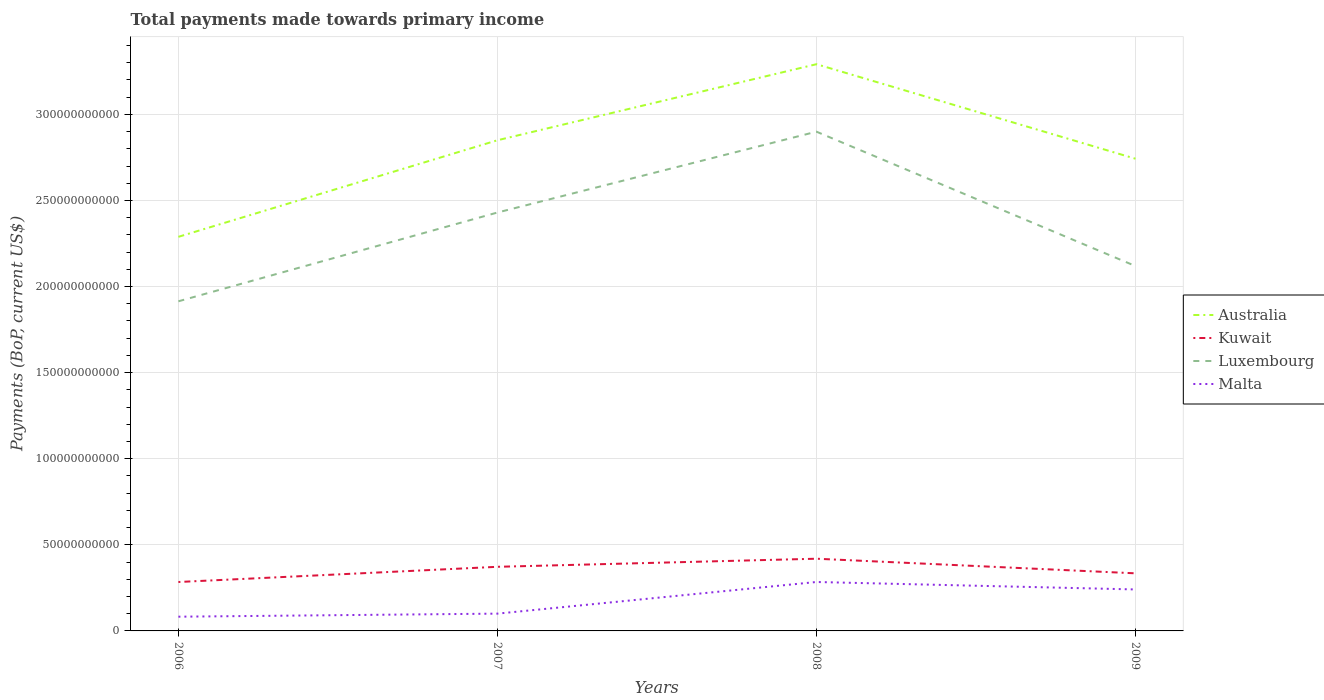How many different coloured lines are there?
Keep it short and to the point. 4. Does the line corresponding to Malta intersect with the line corresponding to Kuwait?
Give a very brief answer. No. Is the number of lines equal to the number of legend labels?
Your answer should be compact. Yes. Across all years, what is the maximum total payments made towards primary income in Malta?
Ensure brevity in your answer.  8.26e+09. What is the total total payments made towards primary income in Kuwait in the graph?
Your answer should be very brief. -4.70e+09. What is the difference between the highest and the second highest total payments made towards primary income in Kuwait?
Ensure brevity in your answer.  1.35e+1. Is the total payments made towards primary income in Australia strictly greater than the total payments made towards primary income in Luxembourg over the years?
Give a very brief answer. No. How many lines are there?
Offer a very short reply. 4. What is the difference between two consecutive major ticks on the Y-axis?
Make the answer very short. 5.00e+1. Does the graph contain grids?
Provide a succinct answer. Yes. How many legend labels are there?
Your answer should be compact. 4. How are the legend labels stacked?
Offer a very short reply. Vertical. What is the title of the graph?
Your response must be concise. Total payments made towards primary income. What is the label or title of the X-axis?
Provide a succinct answer. Years. What is the label or title of the Y-axis?
Ensure brevity in your answer.  Payments (BoP, current US$). What is the Payments (BoP, current US$) of Australia in 2006?
Your answer should be very brief. 2.29e+11. What is the Payments (BoP, current US$) of Kuwait in 2006?
Your answer should be compact. 2.84e+1. What is the Payments (BoP, current US$) in Luxembourg in 2006?
Make the answer very short. 1.91e+11. What is the Payments (BoP, current US$) of Malta in 2006?
Ensure brevity in your answer.  8.26e+09. What is the Payments (BoP, current US$) of Australia in 2007?
Offer a terse response. 2.85e+11. What is the Payments (BoP, current US$) of Kuwait in 2007?
Provide a short and direct response. 3.72e+1. What is the Payments (BoP, current US$) of Luxembourg in 2007?
Your response must be concise. 2.43e+11. What is the Payments (BoP, current US$) in Malta in 2007?
Keep it short and to the point. 1.00e+1. What is the Payments (BoP, current US$) of Australia in 2008?
Provide a short and direct response. 3.29e+11. What is the Payments (BoP, current US$) of Kuwait in 2008?
Keep it short and to the point. 4.19e+1. What is the Payments (BoP, current US$) in Luxembourg in 2008?
Provide a succinct answer. 2.90e+11. What is the Payments (BoP, current US$) in Malta in 2008?
Provide a short and direct response. 2.84e+1. What is the Payments (BoP, current US$) in Australia in 2009?
Offer a very short reply. 2.74e+11. What is the Payments (BoP, current US$) of Kuwait in 2009?
Your response must be concise. 3.34e+1. What is the Payments (BoP, current US$) in Luxembourg in 2009?
Provide a short and direct response. 2.12e+11. What is the Payments (BoP, current US$) in Malta in 2009?
Offer a terse response. 2.41e+1. Across all years, what is the maximum Payments (BoP, current US$) in Australia?
Offer a terse response. 3.29e+11. Across all years, what is the maximum Payments (BoP, current US$) of Kuwait?
Your answer should be compact. 4.19e+1. Across all years, what is the maximum Payments (BoP, current US$) in Luxembourg?
Provide a succinct answer. 2.90e+11. Across all years, what is the maximum Payments (BoP, current US$) in Malta?
Keep it short and to the point. 2.84e+1. Across all years, what is the minimum Payments (BoP, current US$) in Australia?
Ensure brevity in your answer.  2.29e+11. Across all years, what is the minimum Payments (BoP, current US$) in Kuwait?
Your answer should be compact. 2.84e+1. Across all years, what is the minimum Payments (BoP, current US$) of Luxembourg?
Your answer should be compact. 1.91e+11. Across all years, what is the minimum Payments (BoP, current US$) in Malta?
Offer a very short reply. 8.26e+09. What is the total Payments (BoP, current US$) in Australia in the graph?
Your answer should be very brief. 1.12e+12. What is the total Payments (BoP, current US$) in Kuwait in the graph?
Your answer should be very brief. 1.41e+11. What is the total Payments (BoP, current US$) in Luxembourg in the graph?
Your answer should be compact. 9.36e+11. What is the total Payments (BoP, current US$) in Malta in the graph?
Offer a terse response. 7.08e+1. What is the difference between the Payments (BoP, current US$) of Australia in 2006 and that in 2007?
Make the answer very short. -5.61e+1. What is the difference between the Payments (BoP, current US$) of Kuwait in 2006 and that in 2007?
Offer a terse response. -8.83e+09. What is the difference between the Payments (BoP, current US$) in Luxembourg in 2006 and that in 2007?
Provide a short and direct response. -5.16e+1. What is the difference between the Payments (BoP, current US$) in Malta in 2006 and that in 2007?
Provide a succinct answer. -1.78e+09. What is the difference between the Payments (BoP, current US$) in Australia in 2006 and that in 2008?
Your response must be concise. -1.00e+11. What is the difference between the Payments (BoP, current US$) in Kuwait in 2006 and that in 2008?
Provide a short and direct response. -1.35e+1. What is the difference between the Payments (BoP, current US$) of Luxembourg in 2006 and that in 2008?
Offer a very short reply. -9.85e+1. What is the difference between the Payments (BoP, current US$) in Malta in 2006 and that in 2008?
Ensure brevity in your answer.  -2.02e+1. What is the difference between the Payments (BoP, current US$) of Australia in 2006 and that in 2009?
Your answer should be very brief. -4.54e+1. What is the difference between the Payments (BoP, current US$) of Kuwait in 2006 and that in 2009?
Your answer should be compact. -5.04e+09. What is the difference between the Payments (BoP, current US$) of Luxembourg in 2006 and that in 2009?
Make the answer very short. -2.05e+1. What is the difference between the Payments (BoP, current US$) of Malta in 2006 and that in 2009?
Make the answer very short. -1.58e+1. What is the difference between the Payments (BoP, current US$) of Australia in 2007 and that in 2008?
Offer a very short reply. -4.42e+1. What is the difference between the Payments (BoP, current US$) in Kuwait in 2007 and that in 2008?
Your answer should be compact. -4.70e+09. What is the difference between the Payments (BoP, current US$) in Luxembourg in 2007 and that in 2008?
Make the answer very short. -4.70e+1. What is the difference between the Payments (BoP, current US$) in Malta in 2007 and that in 2008?
Your answer should be very brief. -1.84e+1. What is the difference between the Payments (BoP, current US$) of Australia in 2007 and that in 2009?
Your answer should be compact. 1.07e+1. What is the difference between the Payments (BoP, current US$) in Kuwait in 2007 and that in 2009?
Keep it short and to the point. 3.79e+09. What is the difference between the Payments (BoP, current US$) of Luxembourg in 2007 and that in 2009?
Make the answer very short. 3.11e+1. What is the difference between the Payments (BoP, current US$) of Malta in 2007 and that in 2009?
Ensure brevity in your answer.  -1.40e+1. What is the difference between the Payments (BoP, current US$) in Australia in 2008 and that in 2009?
Your response must be concise. 5.49e+1. What is the difference between the Payments (BoP, current US$) of Kuwait in 2008 and that in 2009?
Give a very brief answer. 8.49e+09. What is the difference between the Payments (BoP, current US$) of Luxembourg in 2008 and that in 2009?
Your answer should be very brief. 7.80e+1. What is the difference between the Payments (BoP, current US$) of Malta in 2008 and that in 2009?
Provide a succinct answer. 4.34e+09. What is the difference between the Payments (BoP, current US$) in Australia in 2006 and the Payments (BoP, current US$) in Kuwait in 2007?
Offer a very short reply. 1.92e+11. What is the difference between the Payments (BoP, current US$) of Australia in 2006 and the Payments (BoP, current US$) of Luxembourg in 2007?
Offer a terse response. -1.41e+1. What is the difference between the Payments (BoP, current US$) of Australia in 2006 and the Payments (BoP, current US$) of Malta in 2007?
Make the answer very short. 2.19e+11. What is the difference between the Payments (BoP, current US$) of Kuwait in 2006 and the Payments (BoP, current US$) of Luxembourg in 2007?
Offer a terse response. -2.15e+11. What is the difference between the Payments (BoP, current US$) in Kuwait in 2006 and the Payments (BoP, current US$) in Malta in 2007?
Provide a short and direct response. 1.84e+1. What is the difference between the Payments (BoP, current US$) of Luxembourg in 2006 and the Payments (BoP, current US$) of Malta in 2007?
Your response must be concise. 1.81e+11. What is the difference between the Payments (BoP, current US$) in Australia in 2006 and the Payments (BoP, current US$) in Kuwait in 2008?
Offer a very short reply. 1.87e+11. What is the difference between the Payments (BoP, current US$) in Australia in 2006 and the Payments (BoP, current US$) in Luxembourg in 2008?
Ensure brevity in your answer.  -6.11e+1. What is the difference between the Payments (BoP, current US$) in Australia in 2006 and the Payments (BoP, current US$) in Malta in 2008?
Give a very brief answer. 2.00e+11. What is the difference between the Payments (BoP, current US$) in Kuwait in 2006 and the Payments (BoP, current US$) in Luxembourg in 2008?
Your response must be concise. -2.62e+11. What is the difference between the Payments (BoP, current US$) of Kuwait in 2006 and the Payments (BoP, current US$) of Malta in 2008?
Your answer should be very brief. -6.62e+06. What is the difference between the Payments (BoP, current US$) in Luxembourg in 2006 and the Payments (BoP, current US$) in Malta in 2008?
Offer a very short reply. 1.63e+11. What is the difference between the Payments (BoP, current US$) in Australia in 2006 and the Payments (BoP, current US$) in Kuwait in 2009?
Make the answer very short. 1.95e+11. What is the difference between the Payments (BoP, current US$) in Australia in 2006 and the Payments (BoP, current US$) in Luxembourg in 2009?
Give a very brief answer. 1.70e+1. What is the difference between the Payments (BoP, current US$) of Australia in 2006 and the Payments (BoP, current US$) of Malta in 2009?
Your answer should be compact. 2.05e+11. What is the difference between the Payments (BoP, current US$) in Kuwait in 2006 and the Payments (BoP, current US$) in Luxembourg in 2009?
Give a very brief answer. -1.83e+11. What is the difference between the Payments (BoP, current US$) of Kuwait in 2006 and the Payments (BoP, current US$) of Malta in 2009?
Make the answer very short. 4.33e+09. What is the difference between the Payments (BoP, current US$) in Luxembourg in 2006 and the Payments (BoP, current US$) in Malta in 2009?
Keep it short and to the point. 1.67e+11. What is the difference between the Payments (BoP, current US$) of Australia in 2007 and the Payments (BoP, current US$) of Kuwait in 2008?
Provide a succinct answer. 2.43e+11. What is the difference between the Payments (BoP, current US$) in Australia in 2007 and the Payments (BoP, current US$) in Luxembourg in 2008?
Make the answer very short. -4.99e+09. What is the difference between the Payments (BoP, current US$) in Australia in 2007 and the Payments (BoP, current US$) in Malta in 2008?
Offer a very short reply. 2.57e+11. What is the difference between the Payments (BoP, current US$) of Kuwait in 2007 and the Payments (BoP, current US$) of Luxembourg in 2008?
Ensure brevity in your answer.  -2.53e+11. What is the difference between the Payments (BoP, current US$) of Kuwait in 2007 and the Payments (BoP, current US$) of Malta in 2008?
Ensure brevity in your answer.  8.82e+09. What is the difference between the Payments (BoP, current US$) of Luxembourg in 2007 and the Payments (BoP, current US$) of Malta in 2008?
Give a very brief answer. 2.15e+11. What is the difference between the Payments (BoP, current US$) in Australia in 2007 and the Payments (BoP, current US$) in Kuwait in 2009?
Your response must be concise. 2.52e+11. What is the difference between the Payments (BoP, current US$) of Australia in 2007 and the Payments (BoP, current US$) of Luxembourg in 2009?
Make the answer very short. 7.31e+1. What is the difference between the Payments (BoP, current US$) of Australia in 2007 and the Payments (BoP, current US$) of Malta in 2009?
Your answer should be very brief. 2.61e+11. What is the difference between the Payments (BoP, current US$) of Kuwait in 2007 and the Payments (BoP, current US$) of Luxembourg in 2009?
Offer a very short reply. -1.75e+11. What is the difference between the Payments (BoP, current US$) in Kuwait in 2007 and the Payments (BoP, current US$) in Malta in 2009?
Provide a short and direct response. 1.32e+1. What is the difference between the Payments (BoP, current US$) in Luxembourg in 2007 and the Payments (BoP, current US$) in Malta in 2009?
Provide a succinct answer. 2.19e+11. What is the difference between the Payments (BoP, current US$) in Australia in 2008 and the Payments (BoP, current US$) in Kuwait in 2009?
Your answer should be compact. 2.96e+11. What is the difference between the Payments (BoP, current US$) of Australia in 2008 and the Payments (BoP, current US$) of Luxembourg in 2009?
Keep it short and to the point. 1.17e+11. What is the difference between the Payments (BoP, current US$) of Australia in 2008 and the Payments (BoP, current US$) of Malta in 2009?
Keep it short and to the point. 3.05e+11. What is the difference between the Payments (BoP, current US$) in Kuwait in 2008 and the Payments (BoP, current US$) in Luxembourg in 2009?
Ensure brevity in your answer.  -1.70e+11. What is the difference between the Payments (BoP, current US$) of Kuwait in 2008 and the Payments (BoP, current US$) of Malta in 2009?
Your response must be concise. 1.79e+1. What is the difference between the Payments (BoP, current US$) in Luxembourg in 2008 and the Payments (BoP, current US$) in Malta in 2009?
Your response must be concise. 2.66e+11. What is the average Payments (BoP, current US$) in Australia per year?
Keep it short and to the point. 2.79e+11. What is the average Payments (BoP, current US$) in Kuwait per year?
Your response must be concise. 3.53e+1. What is the average Payments (BoP, current US$) in Luxembourg per year?
Your response must be concise. 2.34e+11. What is the average Payments (BoP, current US$) of Malta per year?
Provide a succinct answer. 1.77e+1. In the year 2006, what is the difference between the Payments (BoP, current US$) of Australia and Payments (BoP, current US$) of Kuwait?
Your answer should be compact. 2.00e+11. In the year 2006, what is the difference between the Payments (BoP, current US$) in Australia and Payments (BoP, current US$) in Luxembourg?
Make the answer very short. 3.74e+1. In the year 2006, what is the difference between the Payments (BoP, current US$) of Australia and Payments (BoP, current US$) of Malta?
Your answer should be very brief. 2.21e+11. In the year 2006, what is the difference between the Payments (BoP, current US$) of Kuwait and Payments (BoP, current US$) of Luxembourg?
Offer a very short reply. -1.63e+11. In the year 2006, what is the difference between the Payments (BoP, current US$) in Kuwait and Payments (BoP, current US$) in Malta?
Provide a short and direct response. 2.01e+1. In the year 2006, what is the difference between the Payments (BoP, current US$) in Luxembourg and Payments (BoP, current US$) in Malta?
Ensure brevity in your answer.  1.83e+11. In the year 2007, what is the difference between the Payments (BoP, current US$) of Australia and Payments (BoP, current US$) of Kuwait?
Keep it short and to the point. 2.48e+11. In the year 2007, what is the difference between the Payments (BoP, current US$) of Australia and Payments (BoP, current US$) of Luxembourg?
Your answer should be compact. 4.20e+1. In the year 2007, what is the difference between the Payments (BoP, current US$) of Australia and Payments (BoP, current US$) of Malta?
Your response must be concise. 2.75e+11. In the year 2007, what is the difference between the Payments (BoP, current US$) in Kuwait and Payments (BoP, current US$) in Luxembourg?
Keep it short and to the point. -2.06e+11. In the year 2007, what is the difference between the Payments (BoP, current US$) of Kuwait and Payments (BoP, current US$) of Malta?
Provide a short and direct response. 2.72e+1. In the year 2007, what is the difference between the Payments (BoP, current US$) in Luxembourg and Payments (BoP, current US$) in Malta?
Make the answer very short. 2.33e+11. In the year 2008, what is the difference between the Payments (BoP, current US$) in Australia and Payments (BoP, current US$) in Kuwait?
Keep it short and to the point. 2.87e+11. In the year 2008, what is the difference between the Payments (BoP, current US$) in Australia and Payments (BoP, current US$) in Luxembourg?
Make the answer very short. 3.92e+1. In the year 2008, what is the difference between the Payments (BoP, current US$) in Australia and Payments (BoP, current US$) in Malta?
Ensure brevity in your answer.  3.01e+11. In the year 2008, what is the difference between the Payments (BoP, current US$) in Kuwait and Payments (BoP, current US$) in Luxembourg?
Your answer should be compact. -2.48e+11. In the year 2008, what is the difference between the Payments (BoP, current US$) of Kuwait and Payments (BoP, current US$) of Malta?
Your response must be concise. 1.35e+1. In the year 2008, what is the difference between the Payments (BoP, current US$) of Luxembourg and Payments (BoP, current US$) of Malta?
Make the answer very short. 2.62e+11. In the year 2009, what is the difference between the Payments (BoP, current US$) of Australia and Payments (BoP, current US$) of Kuwait?
Your answer should be compact. 2.41e+11. In the year 2009, what is the difference between the Payments (BoP, current US$) of Australia and Payments (BoP, current US$) of Luxembourg?
Offer a terse response. 6.23e+1. In the year 2009, what is the difference between the Payments (BoP, current US$) of Australia and Payments (BoP, current US$) of Malta?
Your answer should be compact. 2.50e+11. In the year 2009, what is the difference between the Payments (BoP, current US$) in Kuwait and Payments (BoP, current US$) in Luxembourg?
Your answer should be very brief. -1.78e+11. In the year 2009, what is the difference between the Payments (BoP, current US$) of Kuwait and Payments (BoP, current US$) of Malta?
Give a very brief answer. 9.37e+09. In the year 2009, what is the difference between the Payments (BoP, current US$) in Luxembourg and Payments (BoP, current US$) in Malta?
Ensure brevity in your answer.  1.88e+11. What is the ratio of the Payments (BoP, current US$) in Australia in 2006 to that in 2007?
Make the answer very short. 0.8. What is the ratio of the Payments (BoP, current US$) in Kuwait in 2006 to that in 2007?
Ensure brevity in your answer.  0.76. What is the ratio of the Payments (BoP, current US$) in Luxembourg in 2006 to that in 2007?
Ensure brevity in your answer.  0.79. What is the ratio of the Payments (BoP, current US$) in Malta in 2006 to that in 2007?
Keep it short and to the point. 0.82. What is the ratio of the Payments (BoP, current US$) in Australia in 2006 to that in 2008?
Offer a very short reply. 0.7. What is the ratio of the Payments (BoP, current US$) of Kuwait in 2006 to that in 2008?
Keep it short and to the point. 0.68. What is the ratio of the Payments (BoP, current US$) in Luxembourg in 2006 to that in 2008?
Offer a terse response. 0.66. What is the ratio of the Payments (BoP, current US$) of Malta in 2006 to that in 2008?
Give a very brief answer. 0.29. What is the ratio of the Payments (BoP, current US$) in Australia in 2006 to that in 2009?
Provide a succinct answer. 0.83. What is the ratio of the Payments (BoP, current US$) of Kuwait in 2006 to that in 2009?
Offer a terse response. 0.85. What is the ratio of the Payments (BoP, current US$) of Luxembourg in 2006 to that in 2009?
Your response must be concise. 0.9. What is the ratio of the Payments (BoP, current US$) in Malta in 2006 to that in 2009?
Your answer should be very brief. 0.34. What is the ratio of the Payments (BoP, current US$) in Australia in 2007 to that in 2008?
Provide a succinct answer. 0.87. What is the ratio of the Payments (BoP, current US$) of Kuwait in 2007 to that in 2008?
Offer a terse response. 0.89. What is the ratio of the Payments (BoP, current US$) of Luxembourg in 2007 to that in 2008?
Offer a terse response. 0.84. What is the ratio of the Payments (BoP, current US$) in Malta in 2007 to that in 2008?
Ensure brevity in your answer.  0.35. What is the ratio of the Payments (BoP, current US$) in Australia in 2007 to that in 2009?
Your answer should be very brief. 1.04. What is the ratio of the Payments (BoP, current US$) of Kuwait in 2007 to that in 2009?
Keep it short and to the point. 1.11. What is the ratio of the Payments (BoP, current US$) of Luxembourg in 2007 to that in 2009?
Ensure brevity in your answer.  1.15. What is the ratio of the Payments (BoP, current US$) of Malta in 2007 to that in 2009?
Your answer should be compact. 0.42. What is the ratio of the Payments (BoP, current US$) in Australia in 2008 to that in 2009?
Your response must be concise. 1.2. What is the ratio of the Payments (BoP, current US$) of Kuwait in 2008 to that in 2009?
Ensure brevity in your answer.  1.25. What is the ratio of the Payments (BoP, current US$) in Luxembourg in 2008 to that in 2009?
Give a very brief answer. 1.37. What is the ratio of the Payments (BoP, current US$) in Malta in 2008 to that in 2009?
Provide a short and direct response. 1.18. What is the difference between the highest and the second highest Payments (BoP, current US$) in Australia?
Offer a very short reply. 4.42e+1. What is the difference between the highest and the second highest Payments (BoP, current US$) of Kuwait?
Keep it short and to the point. 4.70e+09. What is the difference between the highest and the second highest Payments (BoP, current US$) of Luxembourg?
Provide a succinct answer. 4.70e+1. What is the difference between the highest and the second highest Payments (BoP, current US$) in Malta?
Provide a succinct answer. 4.34e+09. What is the difference between the highest and the lowest Payments (BoP, current US$) of Australia?
Your response must be concise. 1.00e+11. What is the difference between the highest and the lowest Payments (BoP, current US$) in Kuwait?
Your response must be concise. 1.35e+1. What is the difference between the highest and the lowest Payments (BoP, current US$) in Luxembourg?
Offer a very short reply. 9.85e+1. What is the difference between the highest and the lowest Payments (BoP, current US$) of Malta?
Keep it short and to the point. 2.02e+1. 